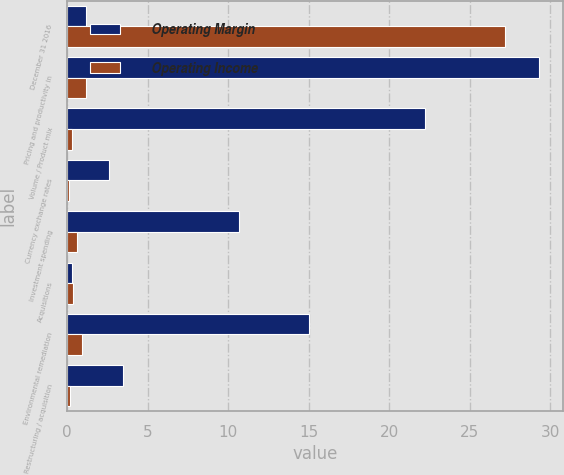Convert chart to OTSL. <chart><loc_0><loc_0><loc_500><loc_500><stacked_bar_chart><ecel><fcel>December 31 2016<fcel>Pricing and productivity in<fcel>Volume / Product mix<fcel>Currency exchange rates<fcel>Investment spending<fcel>Acquisitions<fcel>Environmental remediation<fcel>Restructuring / acquisition<nl><fcel>Operating Margin<fcel>1.2<fcel>29.3<fcel>22.2<fcel>2.6<fcel>10.7<fcel>0.3<fcel>15<fcel>3.5<nl><fcel>Operating Income<fcel>27.2<fcel>1.2<fcel>0.3<fcel>0.1<fcel>0.6<fcel>0.4<fcel>0.9<fcel>0.2<nl></chart> 